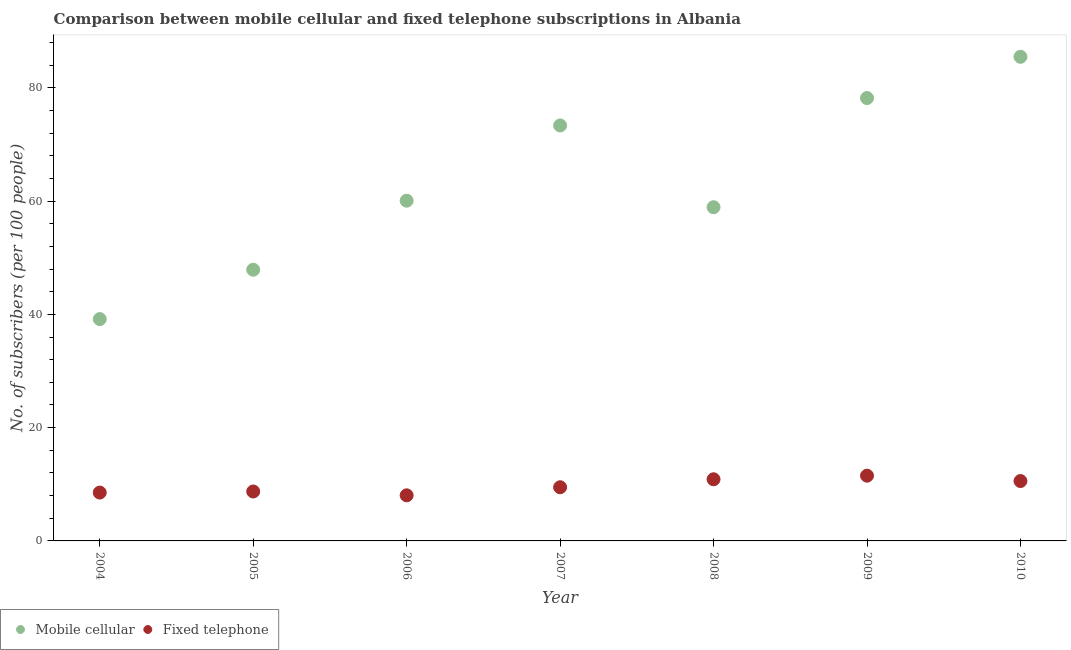How many different coloured dotlines are there?
Your response must be concise. 2. What is the number of mobile cellular subscribers in 2009?
Provide a succinct answer. 78.18. Across all years, what is the maximum number of fixed telephone subscribers?
Your answer should be compact. 11.52. Across all years, what is the minimum number of mobile cellular subscribers?
Your response must be concise. 39.16. In which year was the number of mobile cellular subscribers maximum?
Ensure brevity in your answer.  2010. What is the total number of fixed telephone subscribers in the graph?
Provide a short and direct response. 67.77. What is the difference between the number of mobile cellular subscribers in 2007 and that in 2010?
Ensure brevity in your answer.  -12.12. What is the difference between the number of fixed telephone subscribers in 2004 and the number of mobile cellular subscribers in 2008?
Offer a very short reply. -50.38. What is the average number of mobile cellular subscribers per year?
Offer a terse response. 63.29. In the year 2009, what is the difference between the number of fixed telephone subscribers and number of mobile cellular subscribers?
Provide a short and direct response. -66.67. In how many years, is the number of mobile cellular subscribers greater than 8?
Make the answer very short. 7. What is the ratio of the number of fixed telephone subscribers in 2005 to that in 2009?
Offer a terse response. 0.76. Is the number of fixed telephone subscribers in 2006 less than that in 2010?
Your response must be concise. Yes. What is the difference between the highest and the second highest number of mobile cellular subscribers?
Provide a short and direct response. 7.28. What is the difference between the highest and the lowest number of mobile cellular subscribers?
Your response must be concise. 46.3. In how many years, is the number of fixed telephone subscribers greater than the average number of fixed telephone subscribers taken over all years?
Your answer should be compact. 3. Does the number of mobile cellular subscribers monotonically increase over the years?
Your answer should be very brief. No. How many years are there in the graph?
Ensure brevity in your answer.  7. Does the graph contain any zero values?
Your answer should be compact. No. What is the title of the graph?
Your answer should be very brief. Comparison between mobile cellular and fixed telephone subscriptions in Albania. Does "ODA received" appear as one of the legend labels in the graph?
Provide a short and direct response. No. What is the label or title of the Y-axis?
Offer a terse response. No. of subscribers (per 100 people). What is the No. of subscribers (per 100 people) in Mobile cellular in 2004?
Offer a very short reply. 39.16. What is the No. of subscribers (per 100 people) in Fixed telephone in 2004?
Your answer should be very brief. 8.54. What is the No. of subscribers (per 100 people) in Mobile cellular in 2005?
Your answer should be compact. 47.88. What is the No. of subscribers (per 100 people) of Fixed telephone in 2005?
Provide a succinct answer. 8.73. What is the No. of subscribers (per 100 people) of Mobile cellular in 2006?
Provide a succinct answer. 60.07. What is the No. of subscribers (per 100 people) in Fixed telephone in 2006?
Ensure brevity in your answer.  8.05. What is the No. of subscribers (per 100 people) of Mobile cellular in 2007?
Your answer should be very brief. 73.35. What is the No. of subscribers (per 100 people) of Fixed telephone in 2007?
Give a very brief answer. 9.48. What is the No. of subscribers (per 100 people) of Mobile cellular in 2008?
Offer a terse response. 58.91. What is the No. of subscribers (per 100 people) in Fixed telephone in 2008?
Your answer should be very brief. 10.88. What is the No. of subscribers (per 100 people) of Mobile cellular in 2009?
Keep it short and to the point. 78.18. What is the No. of subscribers (per 100 people) of Fixed telephone in 2009?
Your response must be concise. 11.52. What is the No. of subscribers (per 100 people) of Mobile cellular in 2010?
Your answer should be compact. 85.47. What is the No. of subscribers (per 100 people) of Fixed telephone in 2010?
Your response must be concise. 10.57. Across all years, what is the maximum No. of subscribers (per 100 people) of Mobile cellular?
Provide a succinct answer. 85.47. Across all years, what is the maximum No. of subscribers (per 100 people) of Fixed telephone?
Give a very brief answer. 11.52. Across all years, what is the minimum No. of subscribers (per 100 people) in Mobile cellular?
Offer a very short reply. 39.16. Across all years, what is the minimum No. of subscribers (per 100 people) of Fixed telephone?
Your answer should be very brief. 8.05. What is the total No. of subscribers (per 100 people) of Mobile cellular in the graph?
Your response must be concise. 443.02. What is the total No. of subscribers (per 100 people) in Fixed telephone in the graph?
Provide a short and direct response. 67.77. What is the difference between the No. of subscribers (per 100 people) of Mobile cellular in 2004 and that in 2005?
Keep it short and to the point. -8.71. What is the difference between the No. of subscribers (per 100 people) in Fixed telephone in 2004 and that in 2005?
Provide a short and direct response. -0.19. What is the difference between the No. of subscribers (per 100 people) of Mobile cellular in 2004 and that in 2006?
Provide a short and direct response. -20.9. What is the difference between the No. of subscribers (per 100 people) in Fixed telephone in 2004 and that in 2006?
Your response must be concise. 0.49. What is the difference between the No. of subscribers (per 100 people) in Mobile cellular in 2004 and that in 2007?
Make the answer very short. -34.19. What is the difference between the No. of subscribers (per 100 people) of Fixed telephone in 2004 and that in 2007?
Offer a very short reply. -0.94. What is the difference between the No. of subscribers (per 100 people) of Mobile cellular in 2004 and that in 2008?
Your answer should be compact. -19.75. What is the difference between the No. of subscribers (per 100 people) in Fixed telephone in 2004 and that in 2008?
Make the answer very short. -2.35. What is the difference between the No. of subscribers (per 100 people) in Mobile cellular in 2004 and that in 2009?
Provide a succinct answer. -39.02. What is the difference between the No. of subscribers (per 100 people) in Fixed telephone in 2004 and that in 2009?
Give a very brief answer. -2.98. What is the difference between the No. of subscribers (per 100 people) of Mobile cellular in 2004 and that in 2010?
Offer a terse response. -46.3. What is the difference between the No. of subscribers (per 100 people) of Fixed telephone in 2004 and that in 2010?
Provide a short and direct response. -2.04. What is the difference between the No. of subscribers (per 100 people) of Mobile cellular in 2005 and that in 2006?
Give a very brief answer. -12.19. What is the difference between the No. of subscribers (per 100 people) in Fixed telephone in 2005 and that in 2006?
Keep it short and to the point. 0.68. What is the difference between the No. of subscribers (per 100 people) of Mobile cellular in 2005 and that in 2007?
Make the answer very short. -25.47. What is the difference between the No. of subscribers (per 100 people) of Fixed telephone in 2005 and that in 2007?
Offer a terse response. -0.75. What is the difference between the No. of subscribers (per 100 people) of Mobile cellular in 2005 and that in 2008?
Offer a terse response. -11.03. What is the difference between the No. of subscribers (per 100 people) in Fixed telephone in 2005 and that in 2008?
Give a very brief answer. -2.16. What is the difference between the No. of subscribers (per 100 people) in Mobile cellular in 2005 and that in 2009?
Ensure brevity in your answer.  -30.31. What is the difference between the No. of subscribers (per 100 people) in Fixed telephone in 2005 and that in 2009?
Your answer should be compact. -2.79. What is the difference between the No. of subscribers (per 100 people) in Mobile cellular in 2005 and that in 2010?
Provide a succinct answer. -37.59. What is the difference between the No. of subscribers (per 100 people) in Fixed telephone in 2005 and that in 2010?
Ensure brevity in your answer.  -1.84. What is the difference between the No. of subscribers (per 100 people) of Mobile cellular in 2006 and that in 2007?
Offer a very short reply. -13.28. What is the difference between the No. of subscribers (per 100 people) in Fixed telephone in 2006 and that in 2007?
Offer a very short reply. -1.42. What is the difference between the No. of subscribers (per 100 people) of Mobile cellular in 2006 and that in 2008?
Ensure brevity in your answer.  1.16. What is the difference between the No. of subscribers (per 100 people) of Fixed telephone in 2006 and that in 2008?
Provide a short and direct response. -2.83. What is the difference between the No. of subscribers (per 100 people) of Mobile cellular in 2006 and that in 2009?
Your answer should be compact. -18.12. What is the difference between the No. of subscribers (per 100 people) of Fixed telephone in 2006 and that in 2009?
Provide a succinct answer. -3.47. What is the difference between the No. of subscribers (per 100 people) of Mobile cellular in 2006 and that in 2010?
Keep it short and to the point. -25.4. What is the difference between the No. of subscribers (per 100 people) of Fixed telephone in 2006 and that in 2010?
Ensure brevity in your answer.  -2.52. What is the difference between the No. of subscribers (per 100 people) of Mobile cellular in 2007 and that in 2008?
Your response must be concise. 14.44. What is the difference between the No. of subscribers (per 100 people) of Fixed telephone in 2007 and that in 2008?
Your answer should be very brief. -1.41. What is the difference between the No. of subscribers (per 100 people) of Mobile cellular in 2007 and that in 2009?
Provide a succinct answer. -4.83. What is the difference between the No. of subscribers (per 100 people) of Fixed telephone in 2007 and that in 2009?
Offer a terse response. -2.04. What is the difference between the No. of subscribers (per 100 people) of Mobile cellular in 2007 and that in 2010?
Offer a terse response. -12.12. What is the difference between the No. of subscribers (per 100 people) of Fixed telephone in 2007 and that in 2010?
Your answer should be compact. -1.1. What is the difference between the No. of subscribers (per 100 people) in Mobile cellular in 2008 and that in 2009?
Keep it short and to the point. -19.27. What is the difference between the No. of subscribers (per 100 people) of Fixed telephone in 2008 and that in 2009?
Your response must be concise. -0.63. What is the difference between the No. of subscribers (per 100 people) of Mobile cellular in 2008 and that in 2010?
Give a very brief answer. -26.56. What is the difference between the No. of subscribers (per 100 people) in Fixed telephone in 2008 and that in 2010?
Make the answer very short. 0.31. What is the difference between the No. of subscribers (per 100 people) of Mobile cellular in 2009 and that in 2010?
Your answer should be compact. -7.28. What is the difference between the No. of subscribers (per 100 people) of Fixed telephone in 2009 and that in 2010?
Provide a succinct answer. 0.95. What is the difference between the No. of subscribers (per 100 people) of Mobile cellular in 2004 and the No. of subscribers (per 100 people) of Fixed telephone in 2005?
Offer a terse response. 30.44. What is the difference between the No. of subscribers (per 100 people) of Mobile cellular in 2004 and the No. of subscribers (per 100 people) of Fixed telephone in 2006?
Ensure brevity in your answer.  31.11. What is the difference between the No. of subscribers (per 100 people) in Mobile cellular in 2004 and the No. of subscribers (per 100 people) in Fixed telephone in 2007?
Make the answer very short. 29.69. What is the difference between the No. of subscribers (per 100 people) of Mobile cellular in 2004 and the No. of subscribers (per 100 people) of Fixed telephone in 2008?
Offer a very short reply. 28.28. What is the difference between the No. of subscribers (per 100 people) in Mobile cellular in 2004 and the No. of subscribers (per 100 people) in Fixed telephone in 2009?
Give a very brief answer. 27.64. What is the difference between the No. of subscribers (per 100 people) in Mobile cellular in 2004 and the No. of subscribers (per 100 people) in Fixed telephone in 2010?
Give a very brief answer. 28.59. What is the difference between the No. of subscribers (per 100 people) in Mobile cellular in 2005 and the No. of subscribers (per 100 people) in Fixed telephone in 2006?
Give a very brief answer. 39.83. What is the difference between the No. of subscribers (per 100 people) of Mobile cellular in 2005 and the No. of subscribers (per 100 people) of Fixed telephone in 2007?
Your answer should be compact. 38.4. What is the difference between the No. of subscribers (per 100 people) of Mobile cellular in 2005 and the No. of subscribers (per 100 people) of Fixed telephone in 2008?
Make the answer very short. 36.99. What is the difference between the No. of subscribers (per 100 people) in Mobile cellular in 2005 and the No. of subscribers (per 100 people) in Fixed telephone in 2009?
Make the answer very short. 36.36. What is the difference between the No. of subscribers (per 100 people) in Mobile cellular in 2005 and the No. of subscribers (per 100 people) in Fixed telephone in 2010?
Your answer should be very brief. 37.3. What is the difference between the No. of subscribers (per 100 people) of Mobile cellular in 2006 and the No. of subscribers (per 100 people) of Fixed telephone in 2007?
Make the answer very short. 50.59. What is the difference between the No. of subscribers (per 100 people) of Mobile cellular in 2006 and the No. of subscribers (per 100 people) of Fixed telephone in 2008?
Your answer should be compact. 49.18. What is the difference between the No. of subscribers (per 100 people) in Mobile cellular in 2006 and the No. of subscribers (per 100 people) in Fixed telephone in 2009?
Provide a short and direct response. 48.55. What is the difference between the No. of subscribers (per 100 people) in Mobile cellular in 2006 and the No. of subscribers (per 100 people) in Fixed telephone in 2010?
Provide a succinct answer. 49.49. What is the difference between the No. of subscribers (per 100 people) in Mobile cellular in 2007 and the No. of subscribers (per 100 people) in Fixed telephone in 2008?
Your answer should be very brief. 62.47. What is the difference between the No. of subscribers (per 100 people) of Mobile cellular in 2007 and the No. of subscribers (per 100 people) of Fixed telephone in 2009?
Keep it short and to the point. 61.83. What is the difference between the No. of subscribers (per 100 people) of Mobile cellular in 2007 and the No. of subscribers (per 100 people) of Fixed telephone in 2010?
Ensure brevity in your answer.  62.78. What is the difference between the No. of subscribers (per 100 people) of Mobile cellular in 2008 and the No. of subscribers (per 100 people) of Fixed telephone in 2009?
Make the answer very short. 47.39. What is the difference between the No. of subscribers (per 100 people) in Mobile cellular in 2008 and the No. of subscribers (per 100 people) in Fixed telephone in 2010?
Ensure brevity in your answer.  48.34. What is the difference between the No. of subscribers (per 100 people) in Mobile cellular in 2009 and the No. of subscribers (per 100 people) in Fixed telephone in 2010?
Provide a short and direct response. 67.61. What is the average No. of subscribers (per 100 people) in Mobile cellular per year?
Your answer should be very brief. 63.29. What is the average No. of subscribers (per 100 people) in Fixed telephone per year?
Your answer should be very brief. 9.68. In the year 2004, what is the difference between the No. of subscribers (per 100 people) of Mobile cellular and No. of subscribers (per 100 people) of Fixed telephone?
Your response must be concise. 30.63. In the year 2005, what is the difference between the No. of subscribers (per 100 people) of Mobile cellular and No. of subscribers (per 100 people) of Fixed telephone?
Provide a short and direct response. 39.15. In the year 2006, what is the difference between the No. of subscribers (per 100 people) of Mobile cellular and No. of subscribers (per 100 people) of Fixed telephone?
Ensure brevity in your answer.  52.02. In the year 2007, what is the difference between the No. of subscribers (per 100 people) in Mobile cellular and No. of subscribers (per 100 people) in Fixed telephone?
Offer a terse response. 63.88. In the year 2008, what is the difference between the No. of subscribers (per 100 people) in Mobile cellular and No. of subscribers (per 100 people) in Fixed telephone?
Your answer should be compact. 48.03. In the year 2009, what is the difference between the No. of subscribers (per 100 people) of Mobile cellular and No. of subscribers (per 100 people) of Fixed telephone?
Your response must be concise. 66.67. In the year 2010, what is the difference between the No. of subscribers (per 100 people) of Mobile cellular and No. of subscribers (per 100 people) of Fixed telephone?
Provide a short and direct response. 74.9. What is the ratio of the No. of subscribers (per 100 people) of Mobile cellular in 2004 to that in 2005?
Offer a terse response. 0.82. What is the ratio of the No. of subscribers (per 100 people) of Mobile cellular in 2004 to that in 2006?
Your answer should be very brief. 0.65. What is the ratio of the No. of subscribers (per 100 people) in Fixed telephone in 2004 to that in 2006?
Make the answer very short. 1.06. What is the ratio of the No. of subscribers (per 100 people) of Mobile cellular in 2004 to that in 2007?
Keep it short and to the point. 0.53. What is the ratio of the No. of subscribers (per 100 people) of Fixed telephone in 2004 to that in 2007?
Make the answer very short. 0.9. What is the ratio of the No. of subscribers (per 100 people) in Mobile cellular in 2004 to that in 2008?
Keep it short and to the point. 0.66. What is the ratio of the No. of subscribers (per 100 people) in Fixed telephone in 2004 to that in 2008?
Give a very brief answer. 0.78. What is the ratio of the No. of subscribers (per 100 people) in Mobile cellular in 2004 to that in 2009?
Offer a very short reply. 0.5. What is the ratio of the No. of subscribers (per 100 people) in Fixed telephone in 2004 to that in 2009?
Your answer should be very brief. 0.74. What is the ratio of the No. of subscribers (per 100 people) in Mobile cellular in 2004 to that in 2010?
Keep it short and to the point. 0.46. What is the ratio of the No. of subscribers (per 100 people) of Fixed telephone in 2004 to that in 2010?
Ensure brevity in your answer.  0.81. What is the ratio of the No. of subscribers (per 100 people) in Mobile cellular in 2005 to that in 2006?
Your answer should be compact. 0.8. What is the ratio of the No. of subscribers (per 100 people) of Fixed telephone in 2005 to that in 2006?
Make the answer very short. 1.08. What is the ratio of the No. of subscribers (per 100 people) of Mobile cellular in 2005 to that in 2007?
Your response must be concise. 0.65. What is the ratio of the No. of subscribers (per 100 people) of Fixed telephone in 2005 to that in 2007?
Offer a terse response. 0.92. What is the ratio of the No. of subscribers (per 100 people) in Mobile cellular in 2005 to that in 2008?
Provide a succinct answer. 0.81. What is the ratio of the No. of subscribers (per 100 people) of Fixed telephone in 2005 to that in 2008?
Offer a very short reply. 0.8. What is the ratio of the No. of subscribers (per 100 people) in Mobile cellular in 2005 to that in 2009?
Give a very brief answer. 0.61. What is the ratio of the No. of subscribers (per 100 people) of Fixed telephone in 2005 to that in 2009?
Your response must be concise. 0.76. What is the ratio of the No. of subscribers (per 100 people) in Mobile cellular in 2005 to that in 2010?
Provide a short and direct response. 0.56. What is the ratio of the No. of subscribers (per 100 people) of Fixed telephone in 2005 to that in 2010?
Make the answer very short. 0.83. What is the ratio of the No. of subscribers (per 100 people) of Mobile cellular in 2006 to that in 2007?
Your response must be concise. 0.82. What is the ratio of the No. of subscribers (per 100 people) in Fixed telephone in 2006 to that in 2007?
Ensure brevity in your answer.  0.85. What is the ratio of the No. of subscribers (per 100 people) of Mobile cellular in 2006 to that in 2008?
Ensure brevity in your answer.  1.02. What is the ratio of the No. of subscribers (per 100 people) of Fixed telephone in 2006 to that in 2008?
Ensure brevity in your answer.  0.74. What is the ratio of the No. of subscribers (per 100 people) in Mobile cellular in 2006 to that in 2009?
Your answer should be very brief. 0.77. What is the ratio of the No. of subscribers (per 100 people) of Fixed telephone in 2006 to that in 2009?
Offer a very short reply. 0.7. What is the ratio of the No. of subscribers (per 100 people) in Mobile cellular in 2006 to that in 2010?
Offer a very short reply. 0.7. What is the ratio of the No. of subscribers (per 100 people) in Fixed telephone in 2006 to that in 2010?
Offer a terse response. 0.76. What is the ratio of the No. of subscribers (per 100 people) in Mobile cellular in 2007 to that in 2008?
Provide a short and direct response. 1.25. What is the ratio of the No. of subscribers (per 100 people) in Fixed telephone in 2007 to that in 2008?
Make the answer very short. 0.87. What is the ratio of the No. of subscribers (per 100 people) in Mobile cellular in 2007 to that in 2009?
Keep it short and to the point. 0.94. What is the ratio of the No. of subscribers (per 100 people) in Fixed telephone in 2007 to that in 2009?
Provide a succinct answer. 0.82. What is the ratio of the No. of subscribers (per 100 people) in Mobile cellular in 2007 to that in 2010?
Make the answer very short. 0.86. What is the ratio of the No. of subscribers (per 100 people) of Fixed telephone in 2007 to that in 2010?
Ensure brevity in your answer.  0.9. What is the ratio of the No. of subscribers (per 100 people) of Mobile cellular in 2008 to that in 2009?
Your response must be concise. 0.75. What is the ratio of the No. of subscribers (per 100 people) of Fixed telephone in 2008 to that in 2009?
Provide a succinct answer. 0.94. What is the ratio of the No. of subscribers (per 100 people) of Mobile cellular in 2008 to that in 2010?
Offer a terse response. 0.69. What is the ratio of the No. of subscribers (per 100 people) of Fixed telephone in 2008 to that in 2010?
Give a very brief answer. 1.03. What is the ratio of the No. of subscribers (per 100 people) in Mobile cellular in 2009 to that in 2010?
Keep it short and to the point. 0.91. What is the ratio of the No. of subscribers (per 100 people) in Fixed telephone in 2009 to that in 2010?
Offer a terse response. 1.09. What is the difference between the highest and the second highest No. of subscribers (per 100 people) in Mobile cellular?
Give a very brief answer. 7.28. What is the difference between the highest and the second highest No. of subscribers (per 100 people) in Fixed telephone?
Offer a very short reply. 0.63. What is the difference between the highest and the lowest No. of subscribers (per 100 people) in Mobile cellular?
Your answer should be compact. 46.3. What is the difference between the highest and the lowest No. of subscribers (per 100 people) of Fixed telephone?
Your answer should be compact. 3.47. 